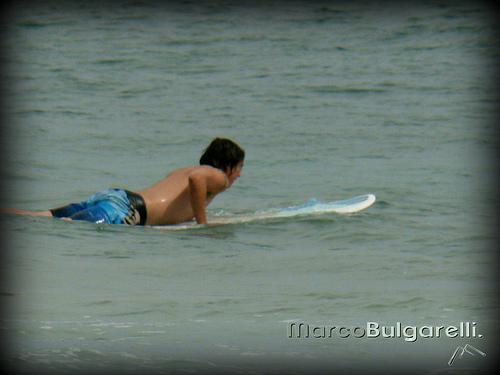Question: what is the boy doing?
Choices:
A. Surfing.
B. Eating.
C. Swimming.
D. Playing.
Answer with the letter. Answer: A Question: when was this picture taken, during the daytime or nighttime?
Choices:
A. Nighttime.
B. The evening.
C. Daytime.
D. Late in the day.
Answer with the letter. Answer: C Question: what is the boy wearing?
Choices:
A. Pants.
B. Board shorts.
C. A shirt.
D. Gym shoes.
Answer with the letter. Answer: B Question: who is surfing?
Choices:
A. A girl.
B. A boy.
C. A professional surfer.
D. A young chid.
Answer with the letter. Answer: B Question: where is he surfing?
Choices:
A. The lake.
B. The river.
C. The ocean.
D. At sea.
Answer with the letter. Answer: C 